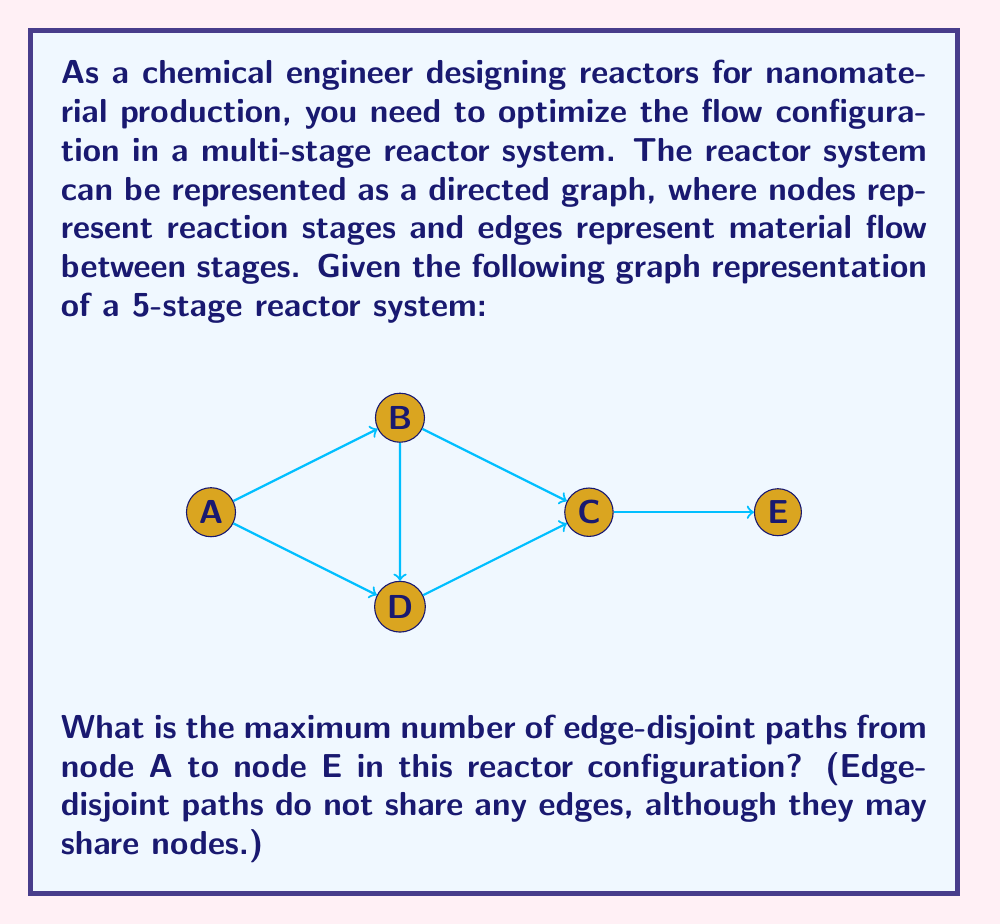Teach me how to tackle this problem. To solve this problem, we can use the max-flow min-cut theorem from graph theory. The maximum number of edge-disjoint paths is equal to the maximum flow from the source (A) to the sink (E) when each edge has a capacity of 1.

Let's solve this step-by-step using the Ford-Fulkerson algorithm:

1) Initialize flow on all edges to 0.

2) Find an augmenting path from A to E:
   Path 1: A → B → C → E (Flow = 1)
   Update residual graph.

3) Find another augmenting path:
   Path 2: A → D → C → E (Flow = 1)
   Update residual graph.

4) Try to find another augmenting path:
   There are no more paths from A to E in the residual graph.

5) The maximum flow is the sum of flows on all augmenting paths:
   Max flow = 1 + 1 = 2

According to the max-flow min-cut theorem, the maximum number of edge-disjoint paths is equal to the maximum flow when edge capacities are 1. 

Therefore, the maximum number of edge-disjoint paths from A to E is 2.

We can verify this by identifying the two edge-disjoint paths:
1) A → B → C → E
2) A → D → C → E

These paths do not share any edges, confirming our result.
Answer: 2 